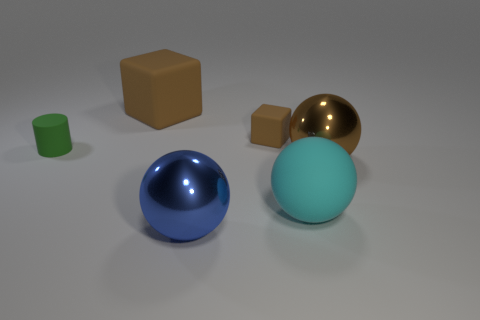What is the shape of the big object that is behind the metal object behind the large cyan object? The shape of the object behind the metal object, which is behind the large cyan-colored sphere, is a cube. This cube is tan or light brown, appearing prominently structured and distinctly three-dimensional with an equal edge length. 